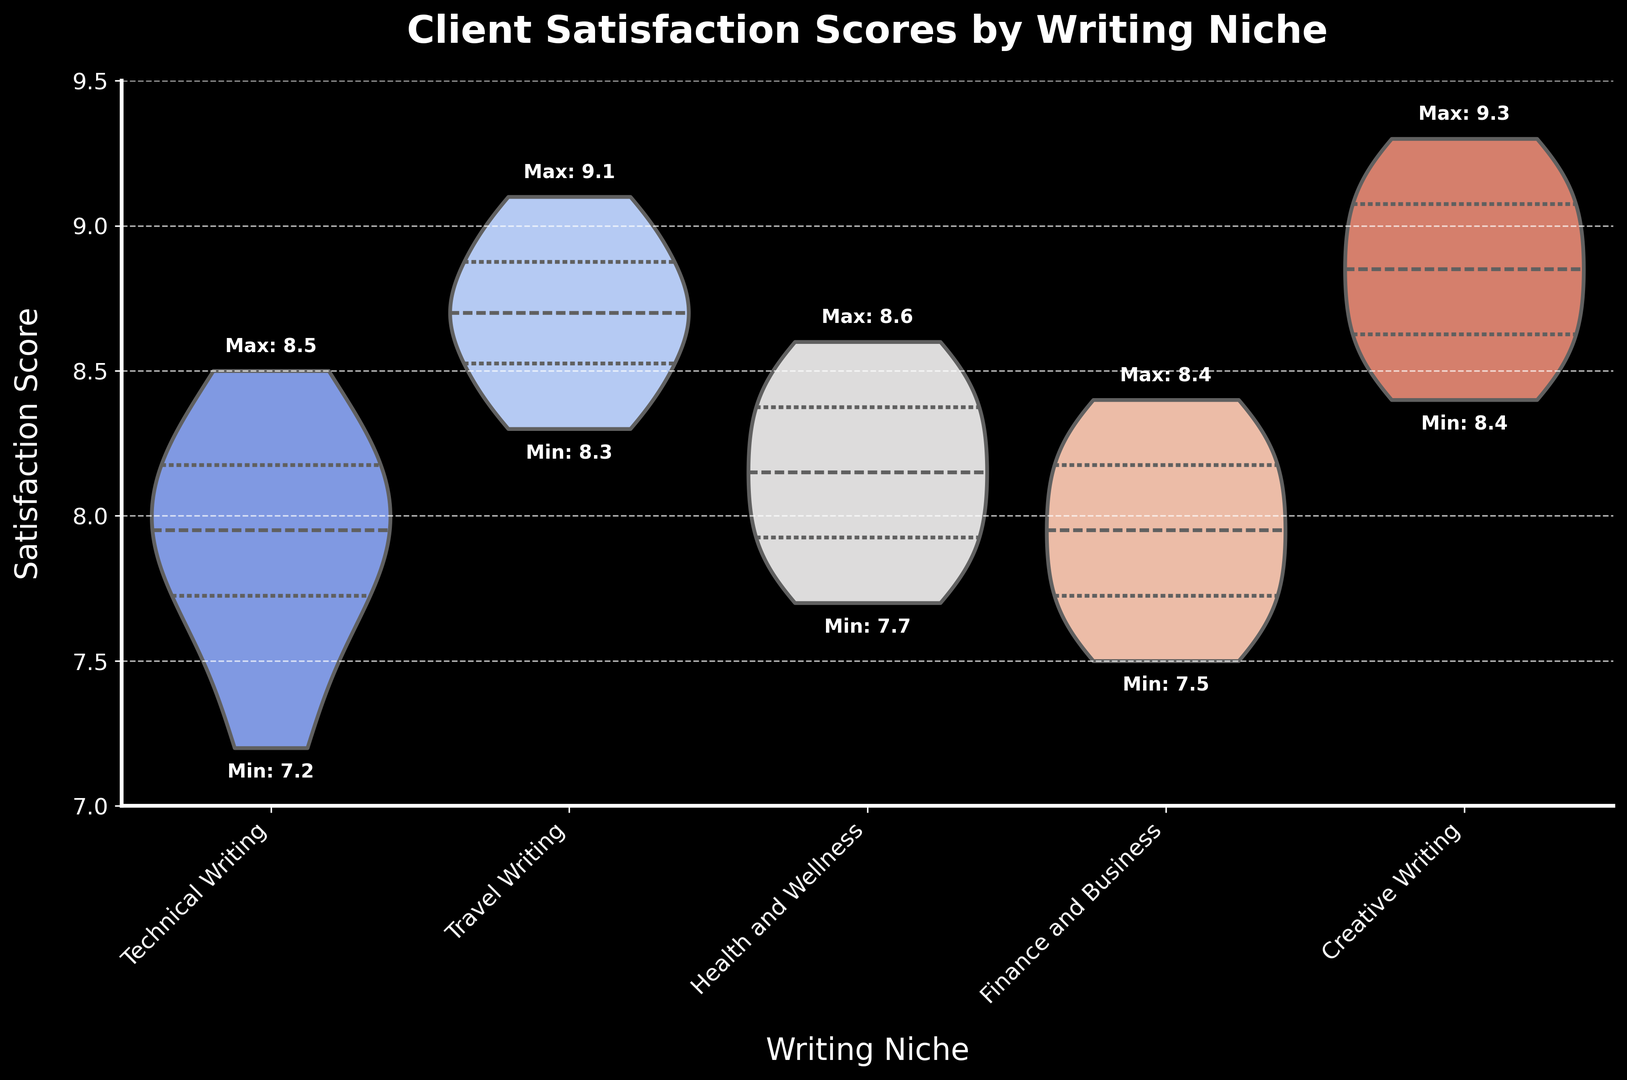What is the range of client satisfaction scores for Technical Writing? The range of client satisfaction scores for Technical Writing can be determined by subtracting the minimum score from the maximum score marked on the plot. Looking at the figure, the maximum score for Technical Writing is highlighted as 8.5 and the minimum score is 7.2. Therefore, the range is 8.5 - 7.2 = 1.3.
Answer: 1.3 Which writing niche has the highest median client satisfaction score? To determine the highest median satisfaction score, we need to look at the horizontal line inside each violin plot, which represents the median. Among the niches, the highest median score appears to be in Creative Writing.
Answer: Creative Writing Which writing niche has the lowest minimum satisfaction score? The lowest minimum satisfaction score can be identified by looking for the lowest value labeled on the figure. Technical Writing has the minimum score marked at 7.2, which is the lowest among all niches.
Answer: Technical Writing List the writing niches in ascending order of their highest satisfaction score. To list the niches in ascending order of their highest satisfaction score, check the maximum values labeled on the figure for each niche and order them. The order is: Technical Writing (8.5), Finance and Business (8.4), Health and Wellness (8.6), Travel Writing (9.1), and Creative Writing (9.3).
Answer: Technical Writing, Finance and Business, Health and Wellness, Travel Writing, Creative Writing What is the interquartile range (IQR) for Travel Writing? The interquartile range (IQR) is the difference between the third quartile (Q3) and first quartile (Q1). From the figure, the lengths of the sections within the box of the Travel Writing violin plot indicate Q1 and Q3. Estimation from the figure shows approximately Q3 is around 8.85 and Q1 is around 8.4. Thus, IQR = 8.85 - 8.4 = 0.45.
Answer: 0.45 Does Health and Wellness have a higher average client satisfaction score than Finance and Business? To determine whether Health and Wellness has a higher average score, we need to compare the median lines within the violin plots of both niches. The median line for Health and Wellness appears slightly higher than that of Finance and Business. Therefore, Health and Wellness has a higher average satisfaction score.
Answer: Yes Which niche shows the largest spread in client satisfaction scores? The spread of scores is indicated by the total height of the violin plot. Technical Writing has the largest spread, ranging from 7.2 to 8.5, giving it a spread of 1.3. This is wider than the spreads of other niches.
Answer: Technical Writing What are the quartiles for Creative Writing? The quartiles for Creative Writing can be inferred from the marks inside the violin plot: The first quartile (Q1) is at the lower bound of the interquartile range (around 8.5), the median (Q2) is the middle horizontal line (around 8.8), and the third quartile (Q3) is the upper bound of the interquartile range (around 9.1).
Answer: Q1: 8.5, Median: 8.8, Q3: 9.1 